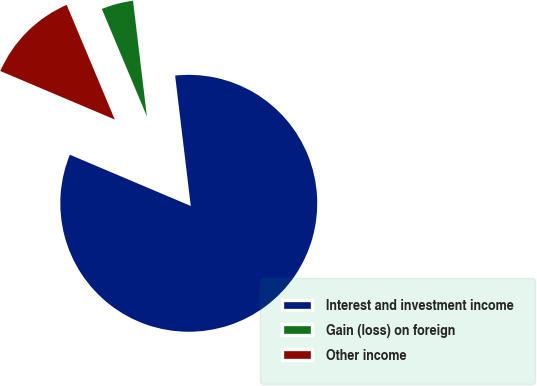Convert chart to OTSL. <chart><loc_0><loc_0><loc_500><loc_500><pie_chart><fcel>Interest and investment income<fcel>Gain (loss) on foreign<fcel>Other income<nl><fcel>83.28%<fcel>4.42%<fcel>12.3%<nl></chart> 